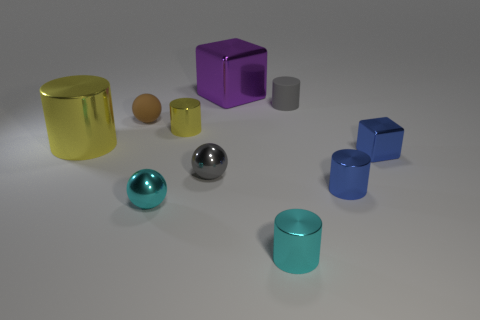Subtract all tiny cyan cylinders. How many cylinders are left? 4 Subtract all green blocks. How many yellow cylinders are left? 2 Subtract all brown balls. How many balls are left? 2 Subtract all blocks. How many objects are left? 8 Subtract 1 cylinders. How many cylinders are left? 4 Subtract all large purple cylinders. Subtract all tiny yellow shiny things. How many objects are left? 9 Add 3 gray cylinders. How many gray cylinders are left? 4 Add 1 brown spheres. How many brown spheres exist? 2 Subtract 0 brown cylinders. How many objects are left? 10 Subtract all yellow cylinders. Subtract all gray blocks. How many cylinders are left? 3 